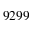<formula> <loc_0><loc_0><loc_500><loc_500>9 2 9 9</formula> 